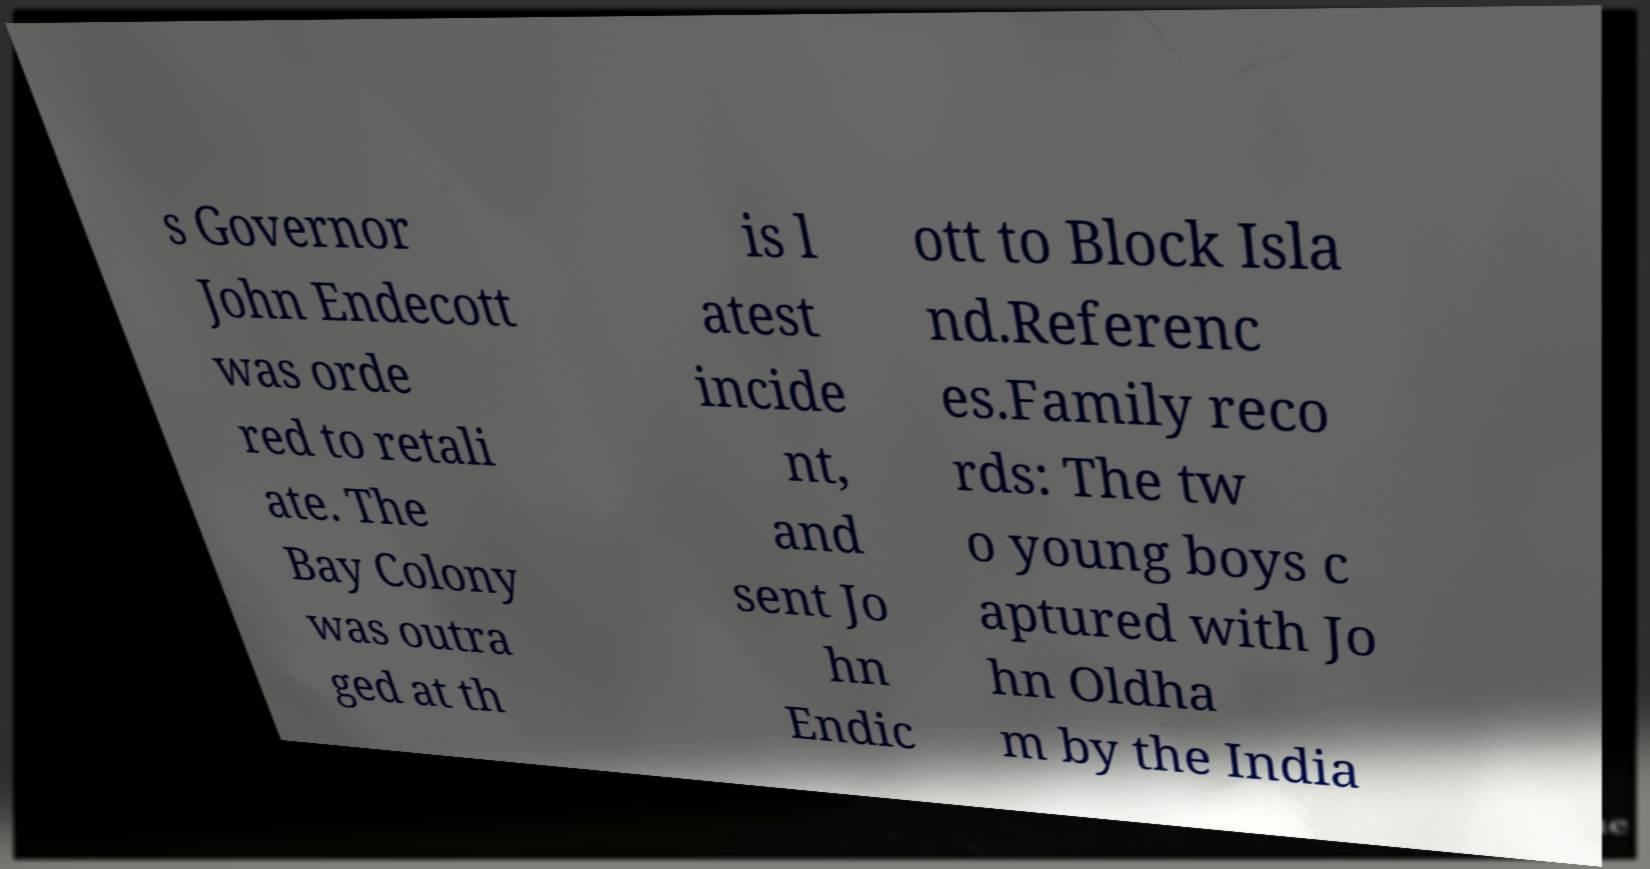Can you accurately transcribe the text from the provided image for me? s Governor John Endecott was orde red to retali ate. The Bay Colony was outra ged at th is l atest incide nt, and sent Jo hn Endic ott to Block Isla nd.Referenc es.Family reco rds: The tw o young boys c aptured with Jo hn Oldha m by the India 